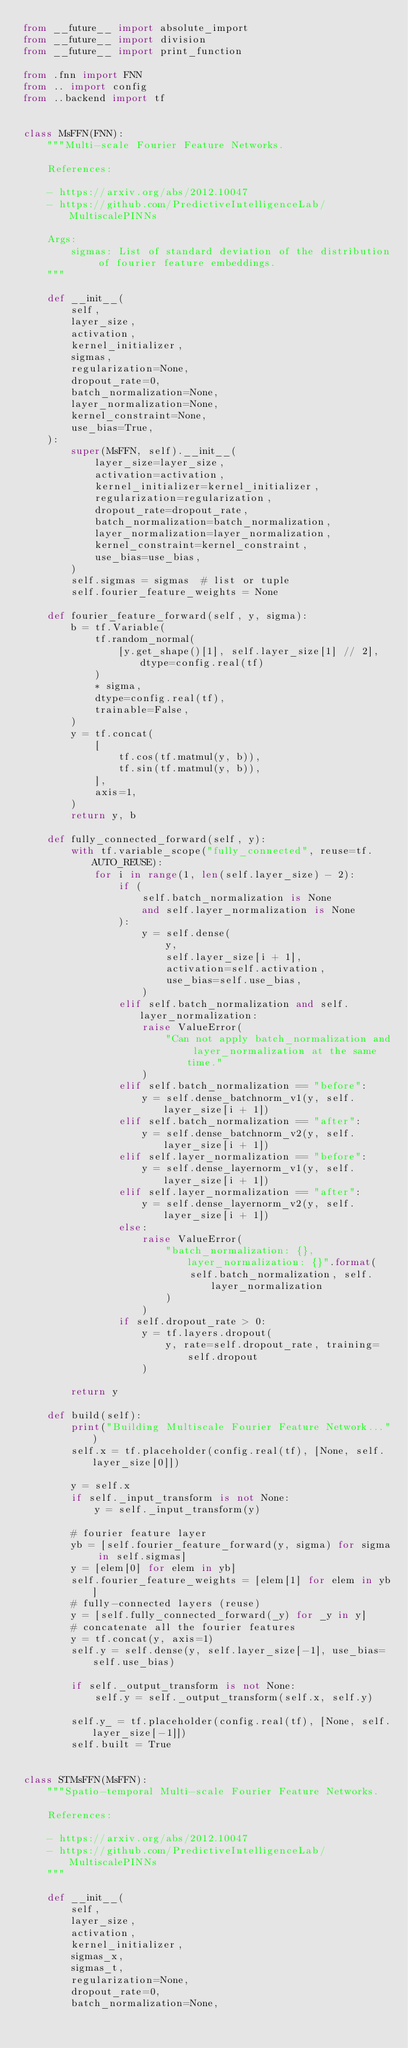<code> <loc_0><loc_0><loc_500><loc_500><_Python_>from __future__ import absolute_import
from __future__ import division
from __future__ import print_function

from .fnn import FNN
from .. import config
from ..backend import tf


class MsFFN(FNN):
    """Multi-scale Fourier Feature Networks.

    References:

    - https://arxiv.org/abs/2012.10047
    - https://github.com/PredictiveIntelligenceLab/MultiscalePINNs

    Args:
        sigmas: List of standard deviation of the distribution of fourier feature embeddings.
    """

    def __init__(
        self,
        layer_size,
        activation,
        kernel_initializer,
        sigmas,
        regularization=None,
        dropout_rate=0,
        batch_normalization=None,
        layer_normalization=None,
        kernel_constraint=None,
        use_bias=True,
    ):
        super(MsFFN, self).__init__(
            layer_size=layer_size,
            activation=activation,
            kernel_initializer=kernel_initializer,
            regularization=regularization,
            dropout_rate=dropout_rate,
            batch_normalization=batch_normalization,
            layer_normalization=layer_normalization,
            kernel_constraint=kernel_constraint,
            use_bias=use_bias,
        )
        self.sigmas = sigmas  # list or tuple
        self.fourier_feature_weights = None

    def fourier_feature_forward(self, y, sigma):
        b = tf.Variable(
            tf.random_normal(
                [y.get_shape()[1], self.layer_size[1] // 2], dtype=config.real(tf)
            )
            * sigma,
            dtype=config.real(tf),
            trainable=False,
        )
        y = tf.concat(
            [
                tf.cos(tf.matmul(y, b)),
                tf.sin(tf.matmul(y, b)),
            ],
            axis=1,
        )
        return y, b

    def fully_connected_forward(self, y):
        with tf.variable_scope("fully_connected", reuse=tf.AUTO_REUSE):
            for i in range(1, len(self.layer_size) - 2):
                if (
                    self.batch_normalization is None
                    and self.layer_normalization is None
                ):
                    y = self.dense(
                        y,
                        self.layer_size[i + 1],
                        activation=self.activation,
                        use_bias=self.use_bias,
                    )
                elif self.batch_normalization and self.layer_normalization:
                    raise ValueError(
                        "Can not apply batch_normalization and layer_normalization at the same time."
                    )
                elif self.batch_normalization == "before":
                    y = self.dense_batchnorm_v1(y, self.layer_size[i + 1])
                elif self.batch_normalization == "after":
                    y = self.dense_batchnorm_v2(y, self.layer_size[i + 1])
                elif self.layer_normalization == "before":
                    y = self.dense_layernorm_v1(y, self.layer_size[i + 1])
                elif self.layer_normalization == "after":
                    y = self.dense_layernorm_v2(y, self.layer_size[i + 1])
                else:
                    raise ValueError(
                        "batch_normalization: {}, layer_normalization: {}".format(
                            self.batch_normalization, self.layer_normalization
                        )
                    )
                if self.dropout_rate > 0:
                    y = tf.layers.dropout(
                        y, rate=self.dropout_rate, training=self.dropout
                    )

        return y

    def build(self):
        print("Building Multiscale Fourier Feature Network...")
        self.x = tf.placeholder(config.real(tf), [None, self.layer_size[0]])

        y = self.x
        if self._input_transform is not None:
            y = self._input_transform(y)

        # fourier feature layer
        yb = [self.fourier_feature_forward(y, sigma) for sigma in self.sigmas]
        y = [elem[0] for elem in yb]
        self.fourier_feature_weights = [elem[1] for elem in yb]
        # fully-connected layers (reuse)
        y = [self.fully_connected_forward(_y) for _y in y]
        # concatenate all the fourier features
        y = tf.concat(y, axis=1)
        self.y = self.dense(y, self.layer_size[-1], use_bias=self.use_bias)

        if self._output_transform is not None:
            self.y = self._output_transform(self.x, self.y)

        self.y_ = tf.placeholder(config.real(tf), [None, self.layer_size[-1]])
        self.built = True


class STMsFFN(MsFFN):
    """Spatio-temporal Multi-scale Fourier Feature Networks.

    References:

    - https://arxiv.org/abs/2012.10047
    - https://github.com/PredictiveIntelligenceLab/MultiscalePINNs
    """

    def __init__(
        self,
        layer_size,
        activation,
        kernel_initializer,
        sigmas_x,
        sigmas_t,
        regularization=None,
        dropout_rate=0,
        batch_normalization=None,</code> 